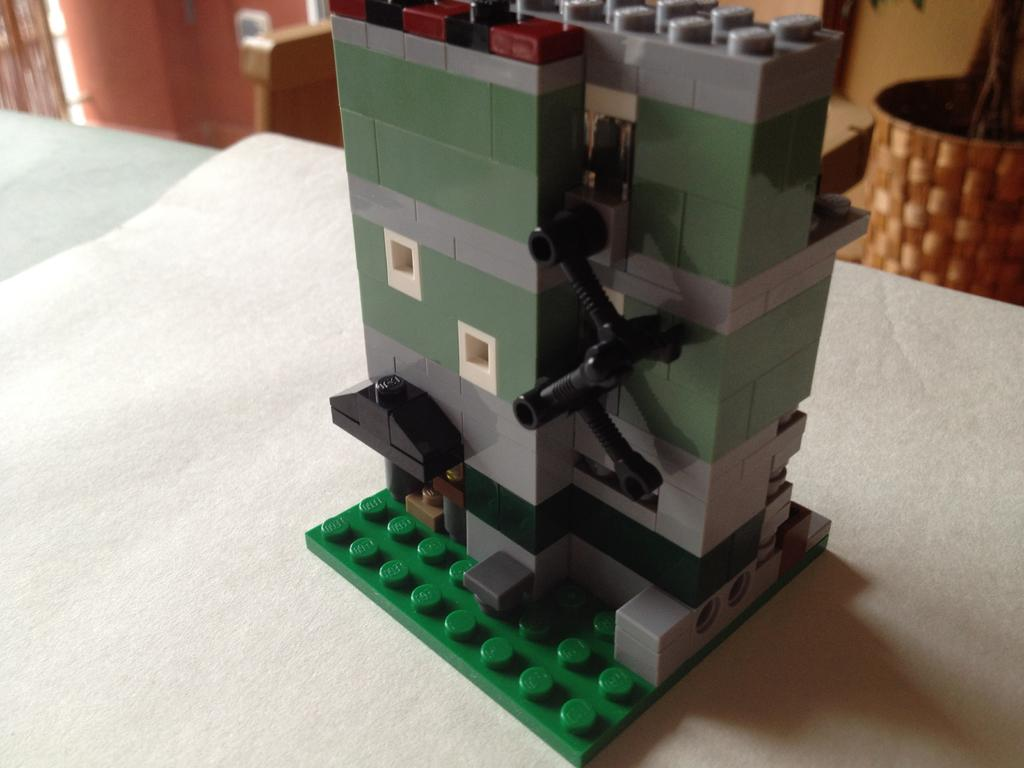What is the main object on the white surface in the image? There is a toy on a white surface in the image. What type of plant can be seen in the image? There is a houseplant in the top right of the image. What is the background of the image? There is a wall in the top left of the image. How does the toy increase in size in the image? The toy does not increase in size in the image; it remains the same size throughout. 